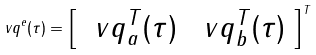Convert formula to latex. <formula><loc_0><loc_0><loc_500><loc_500>\ v q ^ { e } ( \tau ) = \left [ \begin{array} { c c } \ v q _ { a } ^ { T } ( \tau ) & \ v q _ { b } ^ { T } ( \tau ) \end{array} \right ] ^ { T }</formula> 